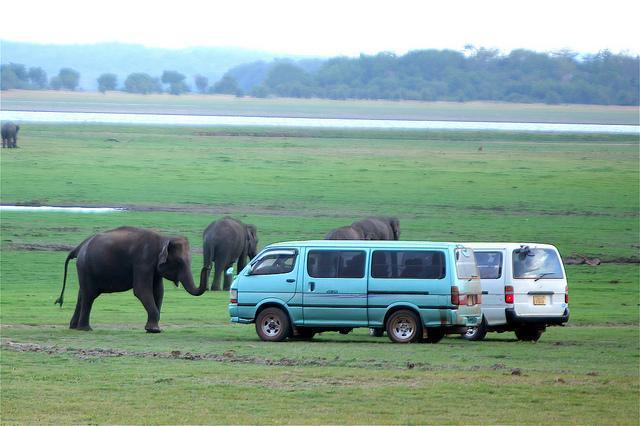How many vehicles are there?
Give a very brief answer. 2. How many elephants are there?
Give a very brief answer. 4. How many elephants can be seen?
Give a very brief answer. 2. How many cars are there?
Give a very brief answer. 2. 